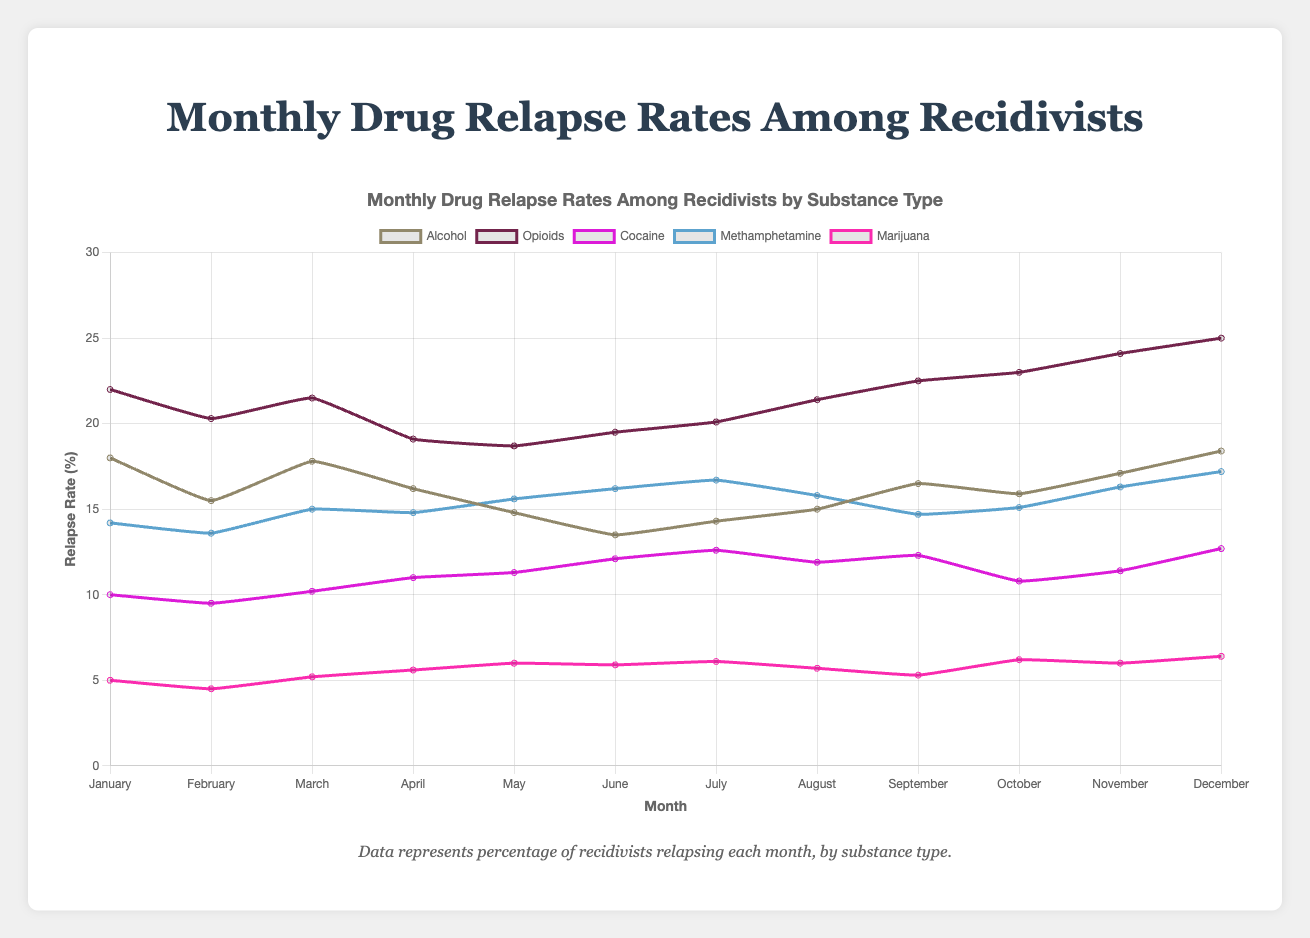Which month has the highest relapse rate for Alcohol? In the line chart, the highest point for Alcohol is in December, with a value of 18.4% relapse rate.
Answer: December Which substance has the highest overall relapse rate in any single month? Reviewing the various lines in the graph, the highest peak is for Opioids in December, with a rate of 25%.
Answer: Opioids What is the difference in relapse rates between January and December for Cocaine? In January, the Cocaine relapse rate is 10.0%, and in December, it is 12.7%. The difference is 12.7% - 10.0% = 2.7%.
Answer: 2.7% Which substance showed an increase in relapse rate from July to August? By looking at the slopes between July and August, we see that the relapse rates increased for Alcohol (14.3% to 15.0%) and Opioids (20.1% to 21.4%).
Answer: Alcohol, Opioids How does the average relapse rate of Opioids compare to that of Marijuana over the entire year? To find the average, sum up the monthly rates for each substance and divide by 12. Opioids: (22.0 + 20.3 + 21.5 + 19.1 + 18.7 + 19.5 + 20.1 + 21.4 + 22.5 + 23.0 + 24.1 + 25.0) / 12 = 21.17%. Marijuana: (5.0 + 4.5 + 5.2 + 5.6 + 6.0 + 5.9 + 6.1 + 5.7 + 5.3 + 6.2 + 6.0 + 6.4) / 12 = 5.67%.
Answer: Opioids have a higher average relapse rate than Marijuana Which month shows the highest combined relapse rate for Alcohol and Methamphetamine? The combined rate is calculated by adding the respective rates for each month. December has the highest combined rate: Alcohol (18.4%) + Methamphetamine (17.2%) = 35.6%.
Answer: December Which substance exhibits the most stable (least volatile) relapse rates throughout the year? The substance with the least variations or smallest range in the relapse rates is Marijuana, where the rates vary from 4.5% to 6.4%.
Answer: Marijuana What is the combined average relapse rate for Alcohol and Cocaine in the month of September? For Alcohol, the September rate is 16.5%, and for Cocaine, it's 12.3%. The combined average is (16.5% + 12.3%) / 2 = 14.4%.
Answer: 14.4% Compare the change in relapse rates of Methamphetamine from May to June with that of Cocaine from June to July. Which change is greater? For Methamphetamine, the rate changes from 15.6% to 16.2%, an increase of 0.6%. For Cocaine, it changes from 12.1% to 12.6%, an increase of 0.5%. The change is greater for Methamphetamine.
Answer: Methamphetamine During which month does Alcohol show the lowest relapse rate, and what is this rate? The lowest point for Alcohol is observed in June, with a relapse rate of 13.5%.
Answer: June, 13.5% 